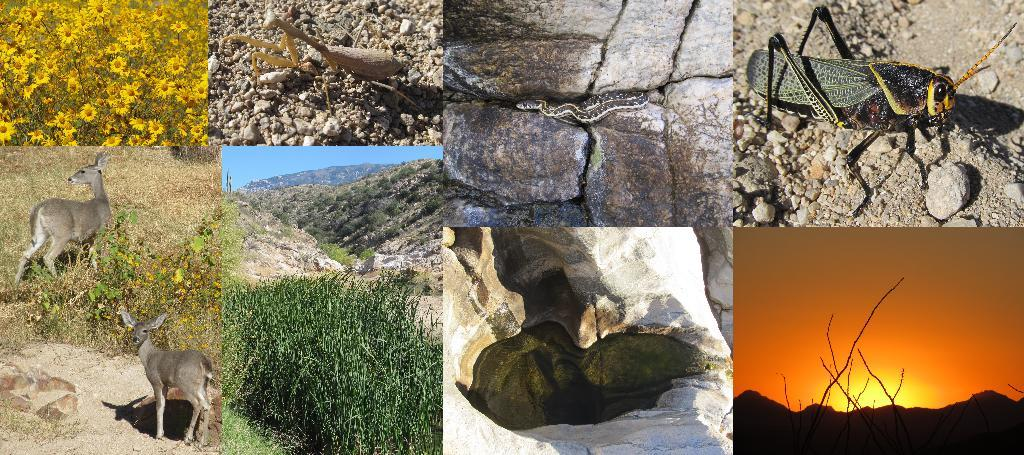What type of artwork is the image? The image is a collage. What types of living organisms can be seen in the image? Animals, insects, and plants are visible in the image. Can you identify any specific animals in the image? Yes, there is a snake in the image. Are there any flowers present in the image? Yes, there are sunflowers in the image. What type of jar is used to store the approval in the image? There is no jar or approval present in the image. 